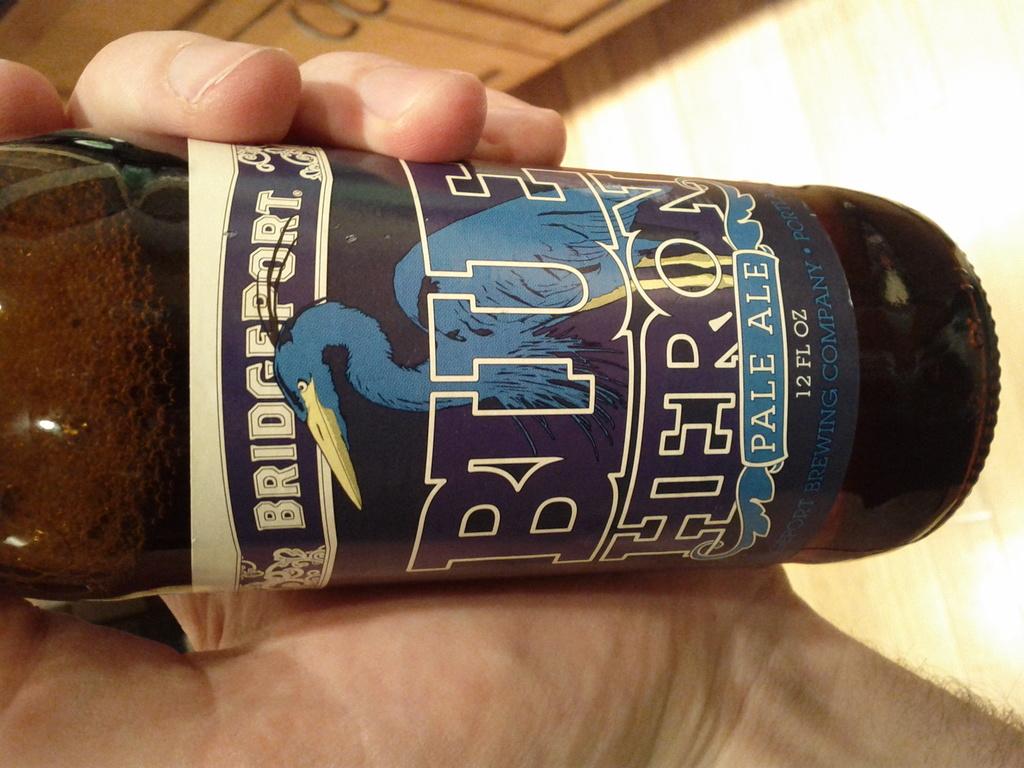What brand of beer?
Provide a short and direct response. Bridgeport. 